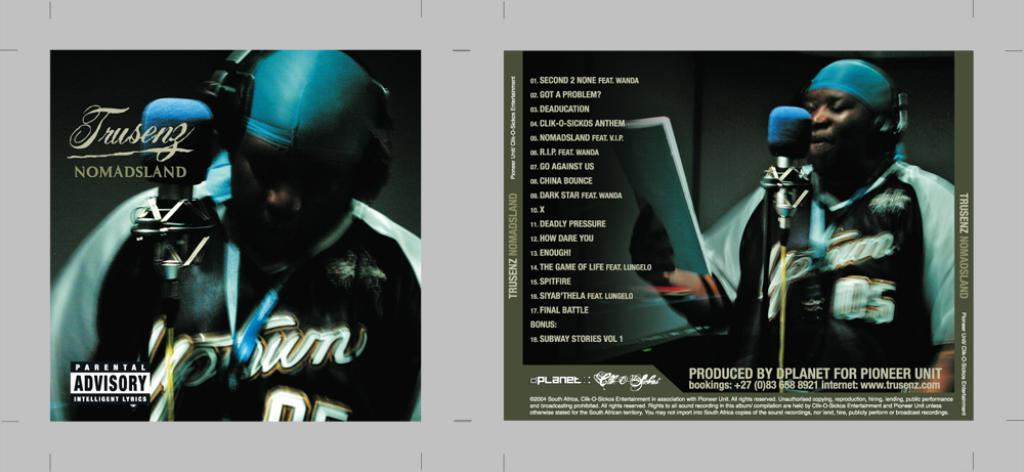Provide a one-sentence caption for the provided image. A front and back cover of a CD with a man singing on it. 